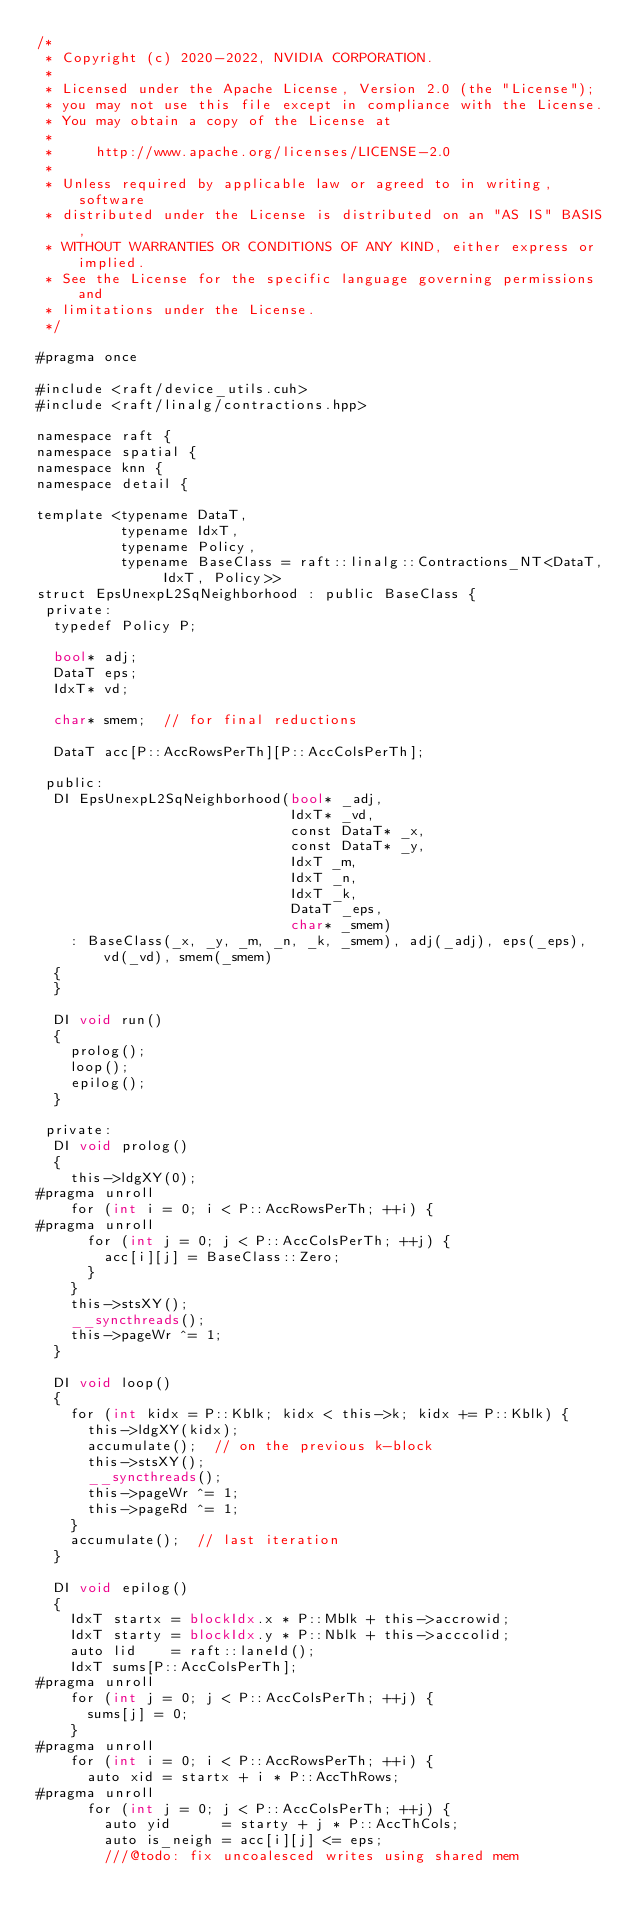<code> <loc_0><loc_0><loc_500><loc_500><_Cuda_>/*
 * Copyright (c) 2020-2022, NVIDIA CORPORATION.
 *
 * Licensed under the Apache License, Version 2.0 (the "License");
 * you may not use this file except in compliance with the License.
 * You may obtain a copy of the License at
 *
 *     http://www.apache.org/licenses/LICENSE-2.0
 *
 * Unless required by applicable law or agreed to in writing, software
 * distributed under the License is distributed on an "AS IS" BASIS,
 * WITHOUT WARRANTIES OR CONDITIONS OF ANY KIND, either express or implied.
 * See the License for the specific language governing permissions and
 * limitations under the License.
 */

#pragma once

#include <raft/device_utils.cuh>
#include <raft/linalg/contractions.hpp>

namespace raft {
namespace spatial {
namespace knn {
namespace detail {

template <typename DataT,
          typename IdxT,
          typename Policy,
          typename BaseClass = raft::linalg::Contractions_NT<DataT, IdxT, Policy>>
struct EpsUnexpL2SqNeighborhood : public BaseClass {
 private:
  typedef Policy P;

  bool* adj;
  DataT eps;
  IdxT* vd;

  char* smem;  // for final reductions

  DataT acc[P::AccRowsPerTh][P::AccColsPerTh];

 public:
  DI EpsUnexpL2SqNeighborhood(bool* _adj,
                              IdxT* _vd,
                              const DataT* _x,
                              const DataT* _y,
                              IdxT _m,
                              IdxT _n,
                              IdxT _k,
                              DataT _eps,
                              char* _smem)
    : BaseClass(_x, _y, _m, _n, _k, _smem), adj(_adj), eps(_eps), vd(_vd), smem(_smem)
  {
  }

  DI void run()
  {
    prolog();
    loop();
    epilog();
  }

 private:
  DI void prolog()
  {
    this->ldgXY(0);
#pragma unroll
    for (int i = 0; i < P::AccRowsPerTh; ++i) {
#pragma unroll
      for (int j = 0; j < P::AccColsPerTh; ++j) {
        acc[i][j] = BaseClass::Zero;
      }
    }
    this->stsXY();
    __syncthreads();
    this->pageWr ^= 1;
  }

  DI void loop()
  {
    for (int kidx = P::Kblk; kidx < this->k; kidx += P::Kblk) {
      this->ldgXY(kidx);
      accumulate();  // on the previous k-block
      this->stsXY();
      __syncthreads();
      this->pageWr ^= 1;
      this->pageRd ^= 1;
    }
    accumulate();  // last iteration
  }

  DI void epilog()
  {
    IdxT startx = blockIdx.x * P::Mblk + this->accrowid;
    IdxT starty = blockIdx.y * P::Nblk + this->acccolid;
    auto lid    = raft::laneId();
    IdxT sums[P::AccColsPerTh];
#pragma unroll
    for (int j = 0; j < P::AccColsPerTh; ++j) {
      sums[j] = 0;
    }
#pragma unroll
    for (int i = 0; i < P::AccRowsPerTh; ++i) {
      auto xid = startx + i * P::AccThRows;
#pragma unroll
      for (int j = 0; j < P::AccColsPerTh; ++j) {
        auto yid      = starty + j * P::AccThCols;
        auto is_neigh = acc[i][j] <= eps;
        ///@todo: fix uncoalesced writes using shared mem</code> 